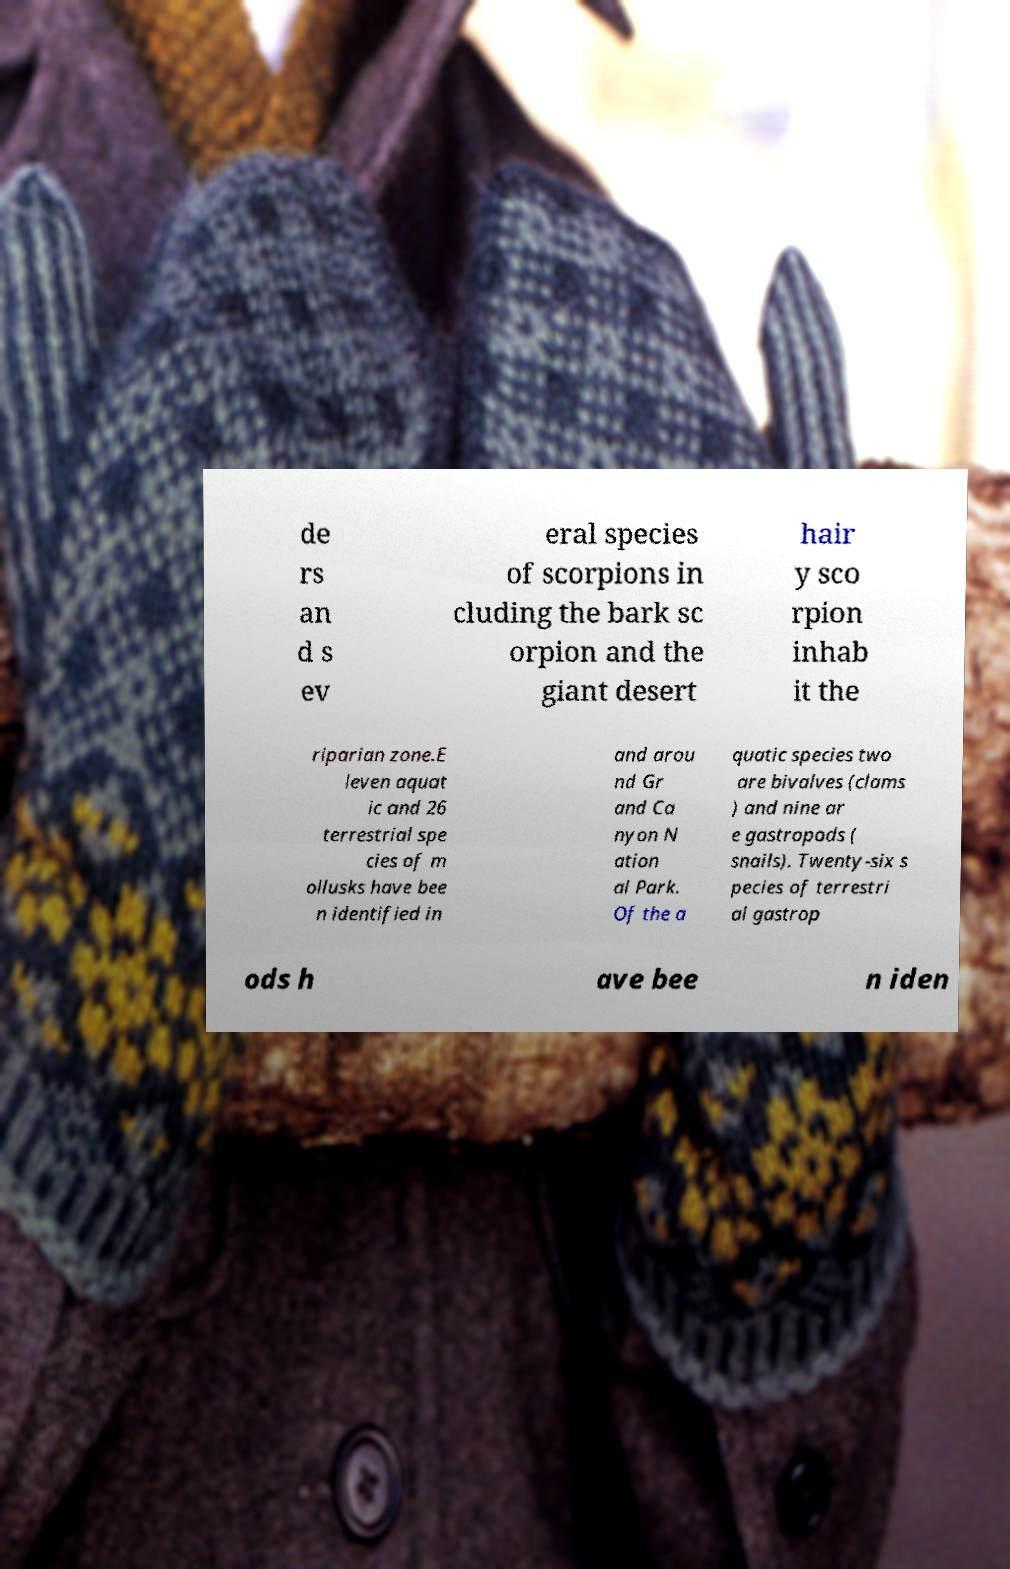Can you read and provide the text displayed in the image?This photo seems to have some interesting text. Can you extract and type it out for me? de rs an d s ev eral species of scorpions in cluding the bark sc orpion and the giant desert hair y sco rpion inhab it the riparian zone.E leven aquat ic and 26 terrestrial spe cies of m ollusks have bee n identified in and arou nd Gr and Ca nyon N ation al Park. Of the a quatic species two are bivalves (clams ) and nine ar e gastropods ( snails). Twenty-six s pecies of terrestri al gastrop ods h ave bee n iden 